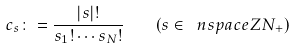Convert formula to latex. <formula><loc_0><loc_0><loc_500><loc_500>c _ { s } \colon = \frac { | s | ! } { s _ { 1 } ! \cdots s _ { N } ! } \quad ( s \in \ n s p a c e { Z } { N } _ { + } )</formula> 